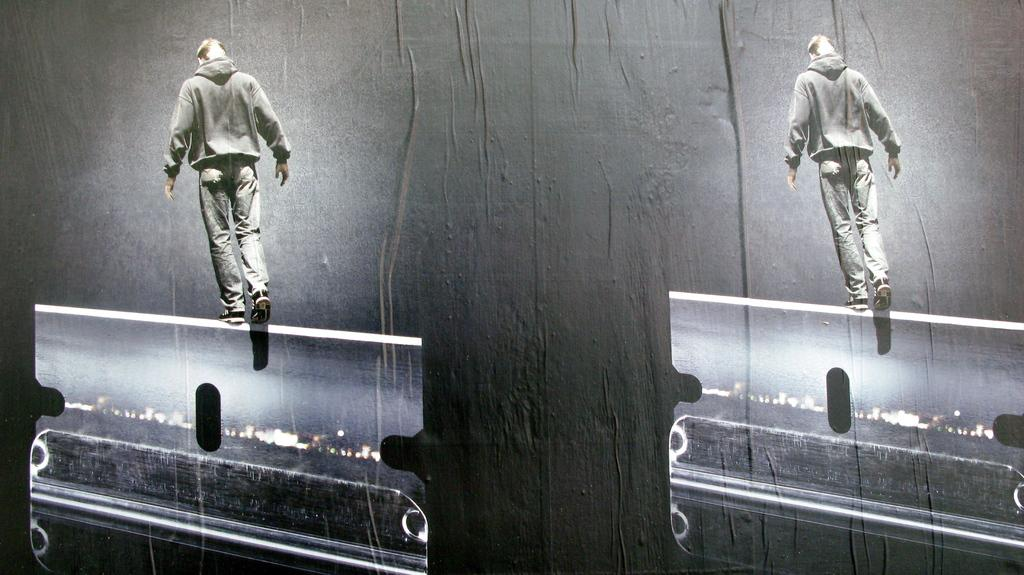What type of visual is depicted in the image? The image is a poster. What is the main subject of the poster? The poster contains a repeated image of a person walking. What is the person walking on in the poster? The person is walking on an object. What type of gate is visible in the image? There is no gate present in the image; it features a repeated image of a person walking on an object. What is the person doing at the end of the image? The image does not depict an end or a specific stopping point for the person walking; it shows a repeated image of the person walking on an object. 